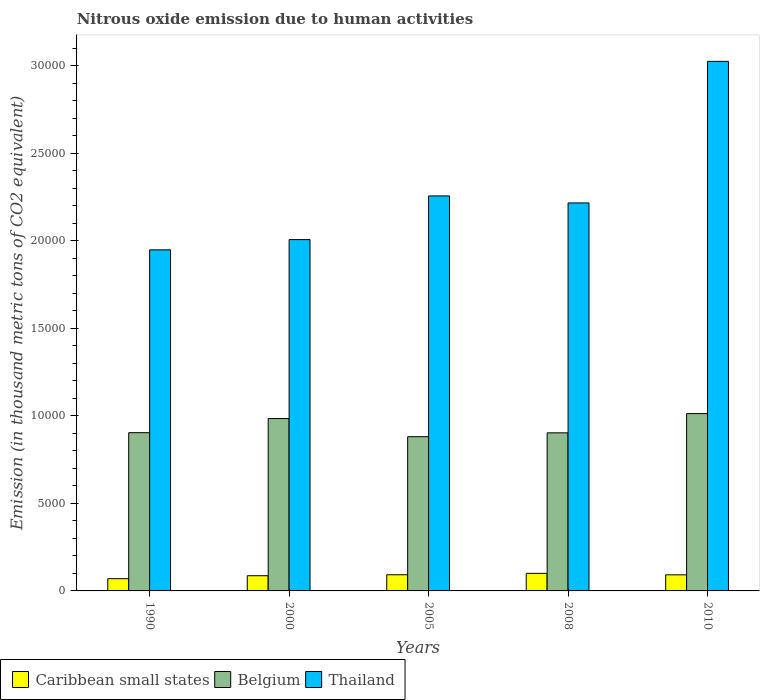How many different coloured bars are there?
Give a very brief answer. 3. How many groups of bars are there?
Provide a short and direct response. 5. What is the amount of nitrous oxide emitted in Belgium in 2000?
Make the answer very short. 9844.1. Across all years, what is the maximum amount of nitrous oxide emitted in Belgium?
Give a very brief answer. 1.01e+04. Across all years, what is the minimum amount of nitrous oxide emitted in Belgium?
Your response must be concise. 8808.6. In which year was the amount of nitrous oxide emitted in Thailand minimum?
Provide a short and direct response. 1990. What is the total amount of nitrous oxide emitted in Belgium in the graph?
Keep it short and to the point. 4.68e+04. What is the difference between the amount of nitrous oxide emitted in Caribbean small states in 1990 and that in 2005?
Offer a terse response. -224.2. What is the difference between the amount of nitrous oxide emitted in Caribbean small states in 2000 and the amount of nitrous oxide emitted in Belgium in 2008?
Ensure brevity in your answer.  -8161. What is the average amount of nitrous oxide emitted in Thailand per year?
Your answer should be compact. 2.29e+04. In the year 1990, what is the difference between the amount of nitrous oxide emitted in Caribbean small states and amount of nitrous oxide emitted in Thailand?
Offer a very short reply. -1.88e+04. In how many years, is the amount of nitrous oxide emitted in Belgium greater than 16000 thousand metric tons?
Your answer should be very brief. 0. What is the ratio of the amount of nitrous oxide emitted in Thailand in 1990 to that in 2005?
Provide a succinct answer. 0.86. Is the difference between the amount of nitrous oxide emitted in Caribbean small states in 2000 and 2010 greater than the difference between the amount of nitrous oxide emitted in Thailand in 2000 and 2010?
Provide a succinct answer. Yes. What is the difference between the highest and the second highest amount of nitrous oxide emitted in Caribbean small states?
Offer a very short reply. 80.1. What is the difference between the highest and the lowest amount of nitrous oxide emitted in Thailand?
Offer a terse response. 1.08e+04. Is the sum of the amount of nitrous oxide emitted in Belgium in 1990 and 2000 greater than the maximum amount of nitrous oxide emitted in Thailand across all years?
Your answer should be compact. No. What does the 3rd bar from the left in 1990 represents?
Offer a very short reply. Thailand. What does the 3rd bar from the right in 2000 represents?
Keep it short and to the point. Caribbean small states. Are all the bars in the graph horizontal?
Keep it short and to the point. No. How many years are there in the graph?
Your answer should be compact. 5. Does the graph contain any zero values?
Offer a terse response. No. Does the graph contain grids?
Offer a very short reply. No. Where does the legend appear in the graph?
Offer a terse response. Bottom left. How are the legend labels stacked?
Keep it short and to the point. Horizontal. What is the title of the graph?
Provide a succinct answer. Nitrous oxide emission due to human activities. Does "Hungary" appear as one of the legend labels in the graph?
Keep it short and to the point. No. What is the label or title of the Y-axis?
Keep it short and to the point. Emission (in thousand metric tons of CO2 equivalent). What is the Emission (in thousand metric tons of CO2 equivalent) in Caribbean small states in 1990?
Provide a short and direct response. 699.1. What is the Emission (in thousand metric tons of CO2 equivalent) in Belgium in 1990?
Provide a succinct answer. 9037.7. What is the Emission (in thousand metric tons of CO2 equivalent) in Thailand in 1990?
Your answer should be very brief. 1.95e+04. What is the Emission (in thousand metric tons of CO2 equivalent) of Caribbean small states in 2000?
Ensure brevity in your answer.  867.7. What is the Emission (in thousand metric tons of CO2 equivalent) of Belgium in 2000?
Your response must be concise. 9844.1. What is the Emission (in thousand metric tons of CO2 equivalent) in Thailand in 2000?
Give a very brief answer. 2.01e+04. What is the Emission (in thousand metric tons of CO2 equivalent) of Caribbean small states in 2005?
Provide a short and direct response. 923.3. What is the Emission (in thousand metric tons of CO2 equivalent) in Belgium in 2005?
Give a very brief answer. 8808.6. What is the Emission (in thousand metric tons of CO2 equivalent) of Thailand in 2005?
Ensure brevity in your answer.  2.26e+04. What is the Emission (in thousand metric tons of CO2 equivalent) of Caribbean small states in 2008?
Provide a short and direct response. 1003.4. What is the Emission (in thousand metric tons of CO2 equivalent) of Belgium in 2008?
Offer a terse response. 9028.7. What is the Emission (in thousand metric tons of CO2 equivalent) of Thailand in 2008?
Your answer should be very brief. 2.22e+04. What is the Emission (in thousand metric tons of CO2 equivalent) of Caribbean small states in 2010?
Your response must be concise. 919.1. What is the Emission (in thousand metric tons of CO2 equivalent) of Belgium in 2010?
Your response must be concise. 1.01e+04. What is the Emission (in thousand metric tons of CO2 equivalent) in Thailand in 2010?
Your answer should be very brief. 3.02e+04. Across all years, what is the maximum Emission (in thousand metric tons of CO2 equivalent) in Caribbean small states?
Provide a short and direct response. 1003.4. Across all years, what is the maximum Emission (in thousand metric tons of CO2 equivalent) in Belgium?
Provide a succinct answer. 1.01e+04. Across all years, what is the maximum Emission (in thousand metric tons of CO2 equivalent) of Thailand?
Your answer should be very brief. 3.02e+04. Across all years, what is the minimum Emission (in thousand metric tons of CO2 equivalent) in Caribbean small states?
Provide a succinct answer. 699.1. Across all years, what is the minimum Emission (in thousand metric tons of CO2 equivalent) of Belgium?
Offer a very short reply. 8808.6. Across all years, what is the minimum Emission (in thousand metric tons of CO2 equivalent) in Thailand?
Make the answer very short. 1.95e+04. What is the total Emission (in thousand metric tons of CO2 equivalent) of Caribbean small states in the graph?
Make the answer very short. 4412.6. What is the total Emission (in thousand metric tons of CO2 equivalent) of Belgium in the graph?
Give a very brief answer. 4.68e+04. What is the total Emission (in thousand metric tons of CO2 equivalent) in Thailand in the graph?
Your answer should be very brief. 1.15e+05. What is the difference between the Emission (in thousand metric tons of CO2 equivalent) in Caribbean small states in 1990 and that in 2000?
Offer a very short reply. -168.6. What is the difference between the Emission (in thousand metric tons of CO2 equivalent) in Belgium in 1990 and that in 2000?
Your response must be concise. -806.4. What is the difference between the Emission (in thousand metric tons of CO2 equivalent) in Thailand in 1990 and that in 2000?
Your answer should be very brief. -586.2. What is the difference between the Emission (in thousand metric tons of CO2 equivalent) of Caribbean small states in 1990 and that in 2005?
Provide a short and direct response. -224.2. What is the difference between the Emission (in thousand metric tons of CO2 equivalent) in Belgium in 1990 and that in 2005?
Make the answer very short. 229.1. What is the difference between the Emission (in thousand metric tons of CO2 equivalent) of Thailand in 1990 and that in 2005?
Your answer should be compact. -3080.2. What is the difference between the Emission (in thousand metric tons of CO2 equivalent) in Caribbean small states in 1990 and that in 2008?
Offer a very short reply. -304.3. What is the difference between the Emission (in thousand metric tons of CO2 equivalent) in Thailand in 1990 and that in 2008?
Offer a very short reply. -2680.3. What is the difference between the Emission (in thousand metric tons of CO2 equivalent) in Caribbean small states in 1990 and that in 2010?
Keep it short and to the point. -220. What is the difference between the Emission (in thousand metric tons of CO2 equivalent) of Belgium in 1990 and that in 2010?
Make the answer very short. -1089.1. What is the difference between the Emission (in thousand metric tons of CO2 equivalent) of Thailand in 1990 and that in 2010?
Ensure brevity in your answer.  -1.08e+04. What is the difference between the Emission (in thousand metric tons of CO2 equivalent) in Caribbean small states in 2000 and that in 2005?
Provide a short and direct response. -55.6. What is the difference between the Emission (in thousand metric tons of CO2 equivalent) of Belgium in 2000 and that in 2005?
Provide a succinct answer. 1035.5. What is the difference between the Emission (in thousand metric tons of CO2 equivalent) of Thailand in 2000 and that in 2005?
Keep it short and to the point. -2494. What is the difference between the Emission (in thousand metric tons of CO2 equivalent) in Caribbean small states in 2000 and that in 2008?
Your response must be concise. -135.7. What is the difference between the Emission (in thousand metric tons of CO2 equivalent) in Belgium in 2000 and that in 2008?
Keep it short and to the point. 815.4. What is the difference between the Emission (in thousand metric tons of CO2 equivalent) in Thailand in 2000 and that in 2008?
Give a very brief answer. -2094.1. What is the difference between the Emission (in thousand metric tons of CO2 equivalent) of Caribbean small states in 2000 and that in 2010?
Your answer should be very brief. -51.4. What is the difference between the Emission (in thousand metric tons of CO2 equivalent) of Belgium in 2000 and that in 2010?
Make the answer very short. -282.7. What is the difference between the Emission (in thousand metric tons of CO2 equivalent) in Thailand in 2000 and that in 2010?
Keep it short and to the point. -1.02e+04. What is the difference between the Emission (in thousand metric tons of CO2 equivalent) of Caribbean small states in 2005 and that in 2008?
Offer a very short reply. -80.1. What is the difference between the Emission (in thousand metric tons of CO2 equivalent) in Belgium in 2005 and that in 2008?
Your response must be concise. -220.1. What is the difference between the Emission (in thousand metric tons of CO2 equivalent) of Thailand in 2005 and that in 2008?
Make the answer very short. 399.9. What is the difference between the Emission (in thousand metric tons of CO2 equivalent) in Belgium in 2005 and that in 2010?
Offer a very short reply. -1318.2. What is the difference between the Emission (in thousand metric tons of CO2 equivalent) in Thailand in 2005 and that in 2010?
Make the answer very short. -7685.5. What is the difference between the Emission (in thousand metric tons of CO2 equivalent) of Caribbean small states in 2008 and that in 2010?
Your answer should be compact. 84.3. What is the difference between the Emission (in thousand metric tons of CO2 equivalent) in Belgium in 2008 and that in 2010?
Offer a terse response. -1098.1. What is the difference between the Emission (in thousand metric tons of CO2 equivalent) of Thailand in 2008 and that in 2010?
Provide a succinct answer. -8085.4. What is the difference between the Emission (in thousand metric tons of CO2 equivalent) of Caribbean small states in 1990 and the Emission (in thousand metric tons of CO2 equivalent) of Belgium in 2000?
Provide a short and direct response. -9145. What is the difference between the Emission (in thousand metric tons of CO2 equivalent) of Caribbean small states in 1990 and the Emission (in thousand metric tons of CO2 equivalent) of Thailand in 2000?
Your answer should be very brief. -1.94e+04. What is the difference between the Emission (in thousand metric tons of CO2 equivalent) of Belgium in 1990 and the Emission (in thousand metric tons of CO2 equivalent) of Thailand in 2000?
Provide a succinct answer. -1.10e+04. What is the difference between the Emission (in thousand metric tons of CO2 equivalent) in Caribbean small states in 1990 and the Emission (in thousand metric tons of CO2 equivalent) in Belgium in 2005?
Your response must be concise. -8109.5. What is the difference between the Emission (in thousand metric tons of CO2 equivalent) in Caribbean small states in 1990 and the Emission (in thousand metric tons of CO2 equivalent) in Thailand in 2005?
Provide a short and direct response. -2.19e+04. What is the difference between the Emission (in thousand metric tons of CO2 equivalent) in Belgium in 1990 and the Emission (in thousand metric tons of CO2 equivalent) in Thailand in 2005?
Keep it short and to the point. -1.35e+04. What is the difference between the Emission (in thousand metric tons of CO2 equivalent) of Caribbean small states in 1990 and the Emission (in thousand metric tons of CO2 equivalent) of Belgium in 2008?
Ensure brevity in your answer.  -8329.6. What is the difference between the Emission (in thousand metric tons of CO2 equivalent) of Caribbean small states in 1990 and the Emission (in thousand metric tons of CO2 equivalent) of Thailand in 2008?
Your answer should be very brief. -2.15e+04. What is the difference between the Emission (in thousand metric tons of CO2 equivalent) of Belgium in 1990 and the Emission (in thousand metric tons of CO2 equivalent) of Thailand in 2008?
Ensure brevity in your answer.  -1.31e+04. What is the difference between the Emission (in thousand metric tons of CO2 equivalent) of Caribbean small states in 1990 and the Emission (in thousand metric tons of CO2 equivalent) of Belgium in 2010?
Your answer should be very brief. -9427.7. What is the difference between the Emission (in thousand metric tons of CO2 equivalent) of Caribbean small states in 1990 and the Emission (in thousand metric tons of CO2 equivalent) of Thailand in 2010?
Offer a terse response. -2.95e+04. What is the difference between the Emission (in thousand metric tons of CO2 equivalent) of Belgium in 1990 and the Emission (in thousand metric tons of CO2 equivalent) of Thailand in 2010?
Keep it short and to the point. -2.12e+04. What is the difference between the Emission (in thousand metric tons of CO2 equivalent) of Caribbean small states in 2000 and the Emission (in thousand metric tons of CO2 equivalent) of Belgium in 2005?
Your answer should be very brief. -7940.9. What is the difference between the Emission (in thousand metric tons of CO2 equivalent) of Caribbean small states in 2000 and the Emission (in thousand metric tons of CO2 equivalent) of Thailand in 2005?
Give a very brief answer. -2.17e+04. What is the difference between the Emission (in thousand metric tons of CO2 equivalent) of Belgium in 2000 and the Emission (in thousand metric tons of CO2 equivalent) of Thailand in 2005?
Provide a succinct answer. -1.27e+04. What is the difference between the Emission (in thousand metric tons of CO2 equivalent) in Caribbean small states in 2000 and the Emission (in thousand metric tons of CO2 equivalent) in Belgium in 2008?
Your answer should be compact. -8161. What is the difference between the Emission (in thousand metric tons of CO2 equivalent) in Caribbean small states in 2000 and the Emission (in thousand metric tons of CO2 equivalent) in Thailand in 2008?
Make the answer very short. -2.13e+04. What is the difference between the Emission (in thousand metric tons of CO2 equivalent) of Belgium in 2000 and the Emission (in thousand metric tons of CO2 equivalent) of Thailand in 2008?
Your answer should be compact. -1.23e+04. What is the difference between the Emission (in thousand metric tons of CO2 equivalent) of Caribbean small states in 2000 and the Emission (in thousand metric tons of CO2 equivalent) of Belgium in 2010?
Offer a very short reply. -9259.1. What is the difference between the Emission (in thousand metric tons of CO2 equivalent) in Caribbean small states in 2000 and the Emission (in thousand metric tons of CO2 equivalent) in Thailand in 2010?
Provide a succinct answer. -2.94e+04. What is the difference between the Emission (in thousand metric tons of CO2 equivalent) in Belgium in 2000 and the Emission (in thousand metric tons of CO2 equivalent) in Thailand in 2010?
Offer a terse response. -2.04e+04. What is the difference between the Emission (in thousand metric tons of CO2 equivalent) in Caribbean small states in 2005 and the Emission (in thousand metric tons of CO2 equivalent) in Belgium in 2008?
Ensure brevity in your answer.  -8105.4. What is the difference between the Emission (in thousand metric tons of CO2 equivalent) in Caribbean small states in 2005 and the Emission (in thousand metric tons of CO2 equivalent) in Thailand in 2008?
Offer a terse response. -2.12e+04. What is the difference between the Emission (in thousand metric tons of CO2 equivalent) in Belgium in 2005 and the Emission (in thousand metric tons of CO2 equivalent) in Thailand in 2008?
Ensure brevity in your answer.  -1.34e+04. What is the difference between the Emission (in thousand metric tons of CO2 equivalent) of Caribbean small states in 2005 and the Emission (in thousand metric tons of CO2 equivalent) of Belgium in 2010?
Give a very brief answer. -9203.5. What is the difference between the Emission (in thousand metric tons of CO2 equivalent) of Caribbean small states in 2005 and the Emission (in thousand metric tons of CO2 equivalent) of Thailand in 2010?
Provide a short and direct response. -2.93e+04. What is the difference between the Emission (in thousand metric tons of CO2 equivalent) in Belgium in 2005 and the Emission (in thousand metric tons of CO2 equivalent) in Thailand in 2010?
Your answer should be very brief. -2.14e+04. What is the difference between the Emission (in thousand metric tons of CO2 equivalent) in Caribbean small states in 2008 and the Emission (in thousand metric tons of CO2 equivalent) in Belgium in 2010?
Your answer should be compact. -9123.4. What is the difference between the Emission (in thousand metric tons of CO2 equivalent) of Caribbean small states in 2008 and the Emission (in thousand metric tons of CO2 equivalent) of Thailand in 2010?
Your answer should be very brief. -2.92e+04. What is the difference between the Emission (in thousand metric tons of CO2 equivalent) in Belgium in 2008 and the Emission (in thousand metric tons of CO2 equivalent) in Thailand in 2010?
Give a very brief answer. -2.12e+04. What is the average Emission (in thousand metric tons of CO2 equivalent) in Caribbean small states per year?
Provide a succinct answer. 882.52. What is the average Emission (in thousand metric tons of CO2 equivalent) in Belgium per year?
Give a very brief answer. 9369.18. What is the average Emission (in thousand metric tons of CO2 equivalent) in Thailand per year?
Your answer should be very brief. 2.29e+04. In the year 1990, what is the difference between the Emission (in thousand metric tons of CO2 equivalent) of Caribbean small states and Emission (in thousand metric tons of CO2 equivalent) of Belgium?
Your answer should be very brief. -8338.6. In the year 1990, what is the difference between the Emission (in thousand metric tons of CO2 equivalent) in Caribbean small states and Emission (in thousand metric tons of CO2 equivalent) in Thailand?
Ensure brevity in your answer.  -1.88e+04. In the year 1990, what is the difference between the Emission (in thousand metric tons of CO2 equivalent) in Belgium and Emission (in thousand metric tons of CO2 equivalent) in Thailand?
Offer a very short reply. -1.04e+04. In the year 2000, what is the difference between the Emission (in thousand metric tons of CO2 equivalent) in Caribbean small states and Emission (in thousand metric tons of CO2 equivalent) in Belgium?
Ensure brevity in your answer.  -8976.4. In the year 2000, what is the difference between the Emission (in thousand metric tons of CO2 equivalent) of Caribbean small states and Emission (in thousand metric tons of CO2 equivalent) of Thailand?
Provide a succinct answer. -1.92e+04. In the year 2000, what is the difference between the Emission (in thousand metric tons of CO2 equivalent) of Belgium and Emission (in thousand metric tons of CO2 equivalent) of Thailand?
Give a very brief answer. -1.02e+04. In the year 2005, what is the difference between the Emission (in thousand metric tons of CO2 equivalent) of Caribbean small states and Emission (in thousand metric tons of CO2 equivalent) of Belgium?
Provide a short and direct response. -7885.3. In the year 2005, what is the difference between the Emission (in thousand metric tons of CO2 equivalent) in Caribbean small states and Emission (in thousand metric tons of CO2 equivalent) in Thailand?
Your answer should be very brief. -2.16e+04. In the year 2005, what is the difference between the Emission (in thousand metric tons of CO2 equivalent) of Belgium and Emission (in thousand metric tons of CO2 equivalent) of Thailand?
Ensure brevity in your answer.  -1.38e+04. In the year 2008, what is the difference between the Emission (in thousand metric tons of CO2 equivalent) in Caribbean small states and Emission (in thousand metric tons of CO2 equivalent) in Belgium?
Make the answer very short. -8025.3. In the year 2008, what is the difference between the Emission (in thousand metric tons of CO2 equivalent) in Caribbean small states and Emission (in thousand metric tons of CO2 equivalent) in Thailand?
Offer a very short reply. -2.12e+04. In the year 2008, what is the difference between the Emission (in thousand metric tons of CO2 equivalent) in Belgium and Emission (in thousand metric tons of CO2 equivalent) in Thailand?
Provide a succinct answer. -1.31e+04. In the year 2010, what is the difference between the Emission (in thousand metric tons of CO2 equivalent) of Caribbean small states and Emission (in thousand metric tons of CO2 equivalent) of Belgium?
Your answer should be very brief. -9207.7. In the year 2010, what is the difference between the Emission (in thousand metric tons of CO2 equivalent) in Caribbean small states and Emission (in thousand metric tons of CO2 equivalent) in Thailand?
Keep it short and to the point. -2.93e+04. In the year 2010, what is the difference between the Emission (in thousand metric tons of CO2 equivalent) of Belgium and Emission (in thousand metric tons of CO2 equivalent) of Thailand?
Give a very brief answer. -2.01e+04. What is the ratio of the Emission (in thousand metric tons of CO2 equivalent) of Caribbean small states in 1990 to that in 2000?
Give a very brief answer. 0.81. What is the ratio of the Emission (in thousand metric tons of CO2 equivalent) of Belgium in 1990 to that in 2000?
Make the answer very short. 0.92. What is the ratio of the Emission (in thousand metric tons of CO2 equivalent) of Thailand in 1990 to that in 2000?
Give a very brief answer. 0.97. What is the ratio of the Emission (in thousand metric tons of CO2 equivalent) in Caribbean small states in 1990 to that in 2005?
Provide a short and direct response. 0.76. What is the ratio of the Emission (in thousand metric tons of CO2 equivalent) in Belgium in 1990 to that in 2005?
Provide a short and direct response. 1.03. What is the ratio of the Emission (in thousand metric tons of CO2 equivalent) of Thailand in 1990 to that in 2005?
Your answer should be compact. 0.86. What is the ratio of the Emission (in thousand metric tons of CO2 equivalent) in Caribbean small states in 1990 to that in 2008?
Keep it short and to the point. 0.7. What is the ratio of the Emission (in thousand metric tons of CO2 equivalent) in Belgium in 1990 to that in 2008?
Your answer should be very brief. 1. What is the ratio of the Emission (in thousand metric tons of CO2 equivalent) of Thailand in 1990 to that in 2008?
Ensure brevity in your answer.  0.88. What is the ratio of the Emission (in thousand metric tons of CO2 equivalent) of Caribbean small states in 1990 to that in 2010?
Keep it short and to the point. 0.76. What is the ratio of the Emission (in thousand metric tons of CO2 equivalent) of Belgium in 1990 to that in 2010?
Keep it short and to the point. 0.89. What is the ratio of the Emission (in thousand metric tons of CO2 equivalent) in Thailand in 1990 to that in 2010?
Provide a succinct answer. 0.64. What is the ratio of the Emission (in thousand metric tons of CO2 equivalent) in Caribbean small states in 2000 to that in 2005?
Ensure brevity in your answer.  0.94. What is the ratio of the Emission (in thousand metric tons of CO2 equivalent) in Belgium in 2000 to that in 2005?
Your answer should be very brief. 1.12. What is the ratio of the Emission (in thousand metric tons of CO2 equivalent) in Thailand in 2000 to that in 2005?
Offer a terse response. 0.89. What is the ratio of the Emission (in thousand metric tons of CO2 equivalent) in Caribbean small states in 2000 to that in 2008?
Provide a short and direct response. 0.86. What is the ratio of the Emission (in thousand metric tons of CO2 equivalent) in Belgium in 2000 to that in 2008?
Your answer should be very brief. 1.09. What is the ratio of the Emission (in thousand metric tons of CO2 equivalent) of Thailand in 2000 to that in 2008?
Ensure brevity in your answer.  0.91. What is the ratio of the Emission (in thousand metric tons of CO2 equivalent) in Caribbean small states in 2000 to that in 2010?
Your answer should be compact. 0.94. What is the ratio of the Emission (in thousand metric tons of CO2 equivalent) of Belgium in 2000 to that in 2010?
Give a very brief answer. 0.97. What is the ratio of the Emission (in thousand metric tons of CO2 equivalent) of Thailand in 2000 to that in 2010?
Offer a terse response. 0.66. What is the ratio of the Emission (in thousand metric tons of CO2 equivalent) in Caribbean small states in 2005 to that in 2008?
Make the answer very short. 0.92. What is the ratio of the Emission (in thousand metric tons of CO2 equivalent) in Belgium in 2005 to that in 2008?
Ensure brevity in your answer.  0.98. What is the ratio of the Emission (in thousand metric tons of CO2 equivalent) in Thailand in 2005 to that in 2008?
Ensure brevity in your answer.  1.02. What is the ratio of the Emission (in thousand metric tons of CO2 equivalent) in Belgium in 2005 to that in 2010?
Keep it short and to the point. 0.87. What is the ratio of the Emission (in thousand metric tons of CO2 equivalent) in Thailand in 2005 to that in 2010?
Give a very brief answer. 0.75. What is the ratio of the Emission (in thousand metric tons of CO2 equivalent) of Caribbean small states in 2008 to that in 2010?
Your response must be concise. 1.09. What is the ratio of the Emission (in thousand metric tons of CO2 equivalent) of Belgium in 2008 to that in 2010?
Provide a short and direct response. 0.89. What is the ratio of the Emission (in thousand metric tons of CO2 equivalent) in Thailand in 2008 to that in 2010?
Offer a terse response. 0.73. What is the difference between the highest and the second highest Emission (in thousand metric tons of CO2 equivalent) of Caribbean small states?
Your answer should be very brief. 80.1. What is the difference between the highest and the second highest Emission (in thousand metric tons of CO2 equivalent) of Belgium?
Provide a succinct answer. 282.7. What is the difference between the highest and the second highest Emission (in thousand metric tons of CO2 equivalent) in Thailand?
Offer a very short reply. 7685.5. What is the difference between the highest and the lowest Emission (in thousand metric tons of CO2 equivalent) in Caribbean small states?
Keep it short and to the point. 304.3. What is the difference between the highest and the lowest Emission (in thousand metric tons of CO2 equivalent) of Belgium?
Keep it short and to the point. 1318.2. What is the difference between the highest and the lowest Emission (in thousand metric tons of CO2 equivalent) in Thailand?
Offer a terse response. 1.08e+04. 